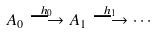<formula> <loc_0><loc_0><loc_500><loc_500>A _ { 0 } \stackrel { h _ { 0 } } { \longrightarrow } A _ { 1 } \stackrel { h _ { 1 } } { \longrightarrow } \cdots</formula> 